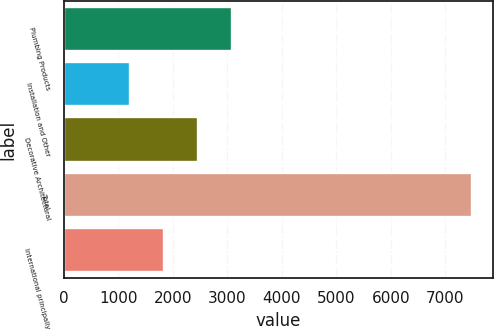Convert chart. <chart><loc_0><loc_0><loc_500><loc_500><bar_chart><fcel>Plumbing Products<fcel>Installation and Other<fcel>Decorative Architectural<fcel>Total<fcel>International principally<nl><fcel>3094.8<fcel>1209<fcel>2466.2<fcel>7495<fcel>1837.6<nl></chart> 